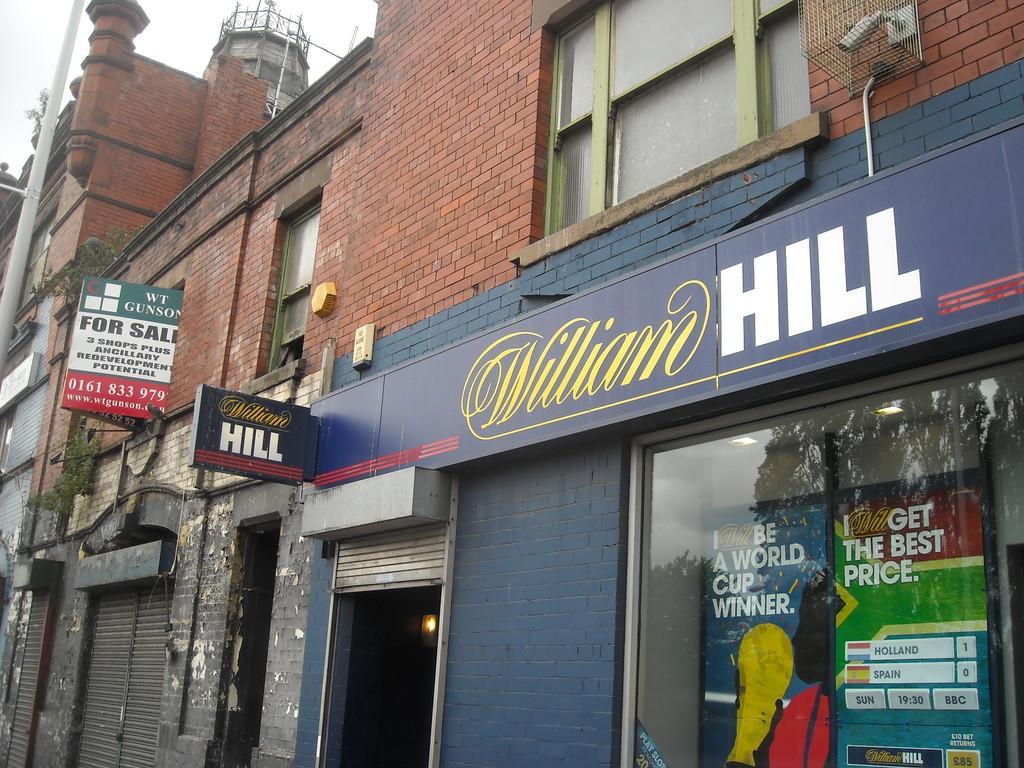Could you give a brief overview of what you see in this image? In this image, we can see a building, we can see some shops, there is hoarding, we can see some words, we can see the pole and the sky. 